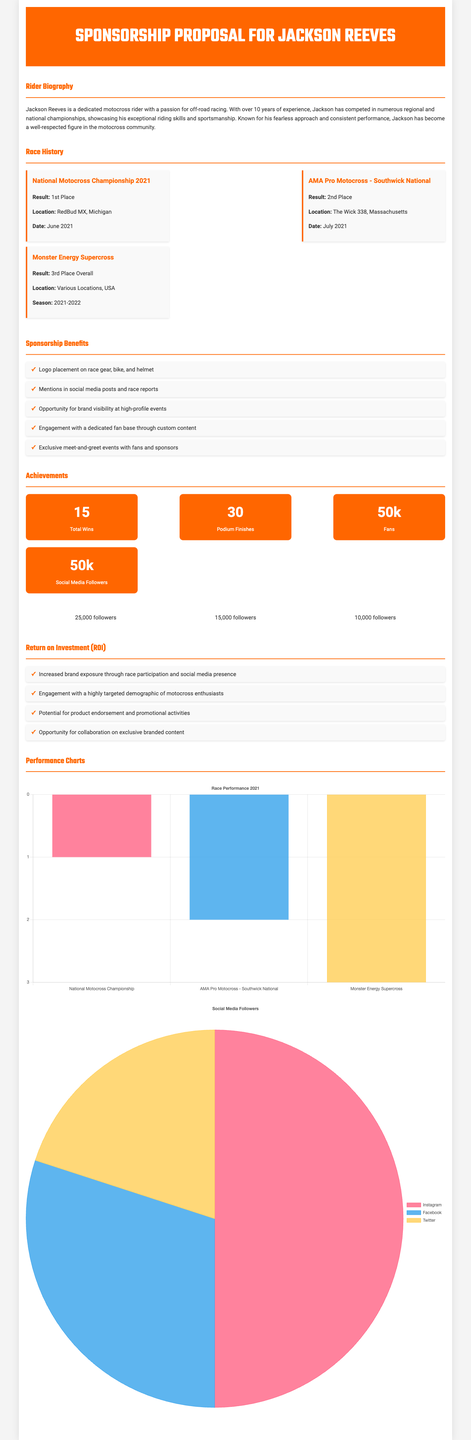What is the rider's name? The rider's name is mentioned in the title of the proposal.
Answer: Jackson Reeves How many years of experience does Jackson have? The rider biography mentions the number of years of experience Jackson has as a motocross rider.
Answer: 10 years Which championship did Jackson win in 2021? The race history section provides the race title and the result that indicates the winning championship.
Answer: National Motocross Championship What is the total number of wins Jackson has? The achievements section lists the total number of wins Jackson has achieved throughout his career.
Answer: 15 What was Jackson's result at the AMA Pro Motocross - Southwick National? The race history section specifies the result of the particular race.
Answer: 2nd Place What type of chart is used for race performance? The document describes the chart type depicted for race performance data in the performance charts section.
Answer: Bar What are the benefits of sponsorship? The document lists specific advantages in the sponsorship benefits section, showing what sponsors will gain.
Answer: Logo placement on race gear, bike, and helmet How many followers does Jackson have on Instagram? The social media section provides specific follower counts for Jackson’s social media platforms.
Answer: 25,000 How many social media platforms are listed in the document? The social media section indicates the variety of platforms where Jackson has a presence.
Answer: 3 